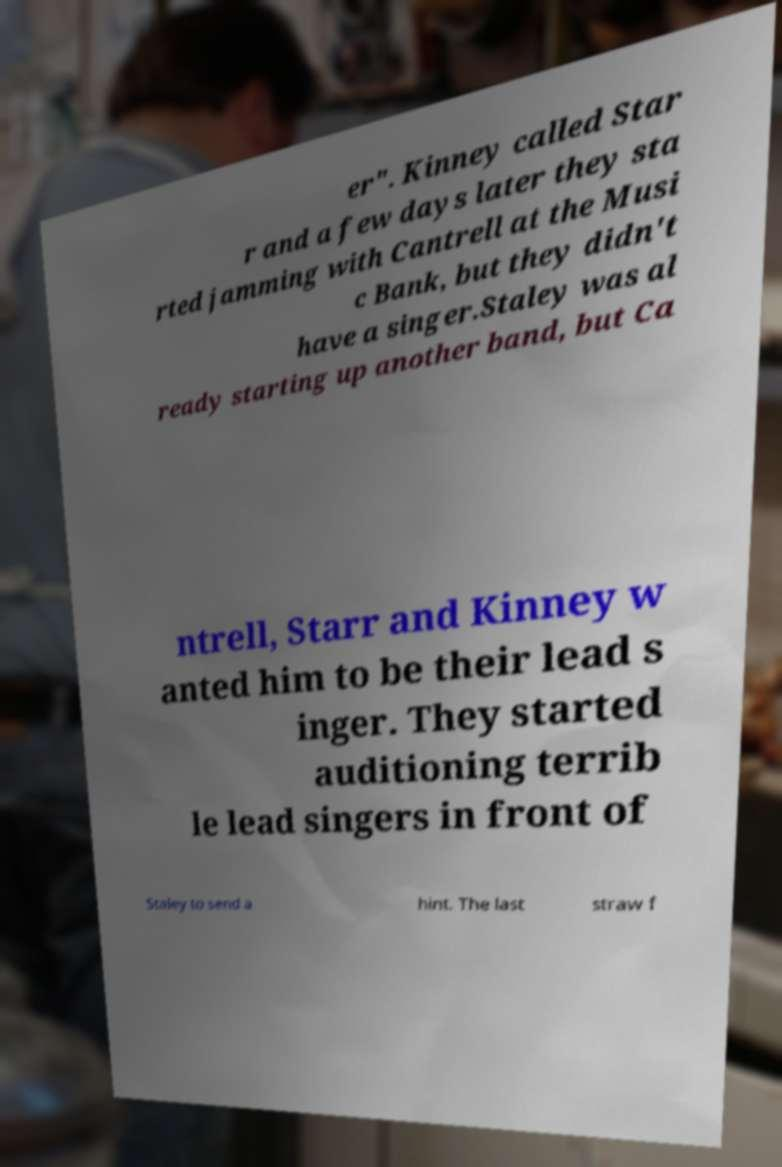Could you extract and type out the text from this image? er". Kinney called Star r and a few days later they sta rted jamming with Cantrell at the Musi c Bank, but they didn't have a singer.Staley was al ready starting up another band, but Ca ntrell, Starr and Kinney w anted him to be their lead s inger. They started auditioning terrib le lead singers in front of Staley to send a hint. The last straw f 